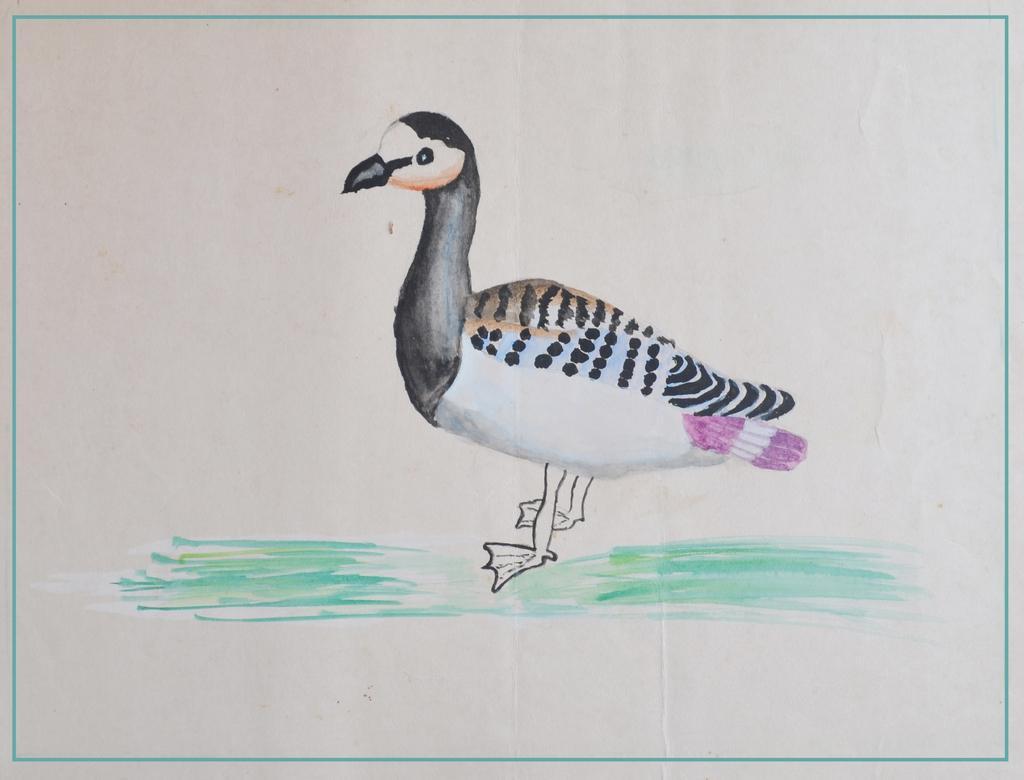Describe this image in one or two sentences. In this picture I can see a drawing of a duck, on the paper. 